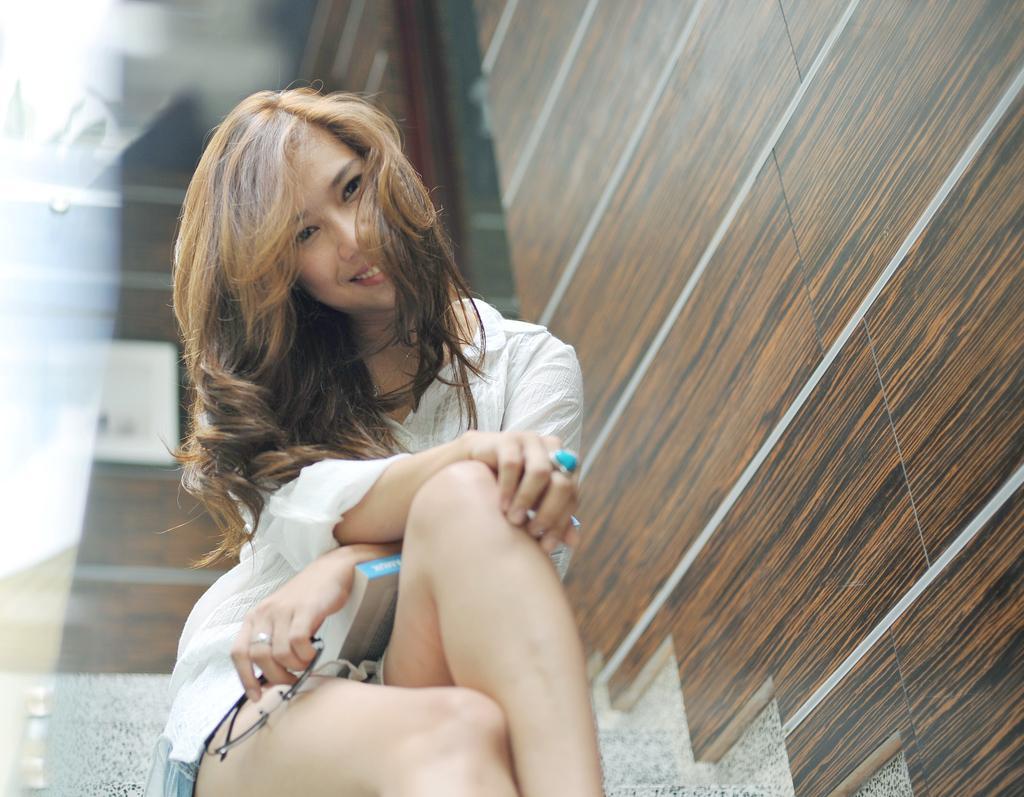In one or two sentences, can you explain what this image depicts? In the image we can see a girl sitting, wearing clothes and finger ring. She is holding spectacles and there is a book on her lap. Here we can see wooden wall and the background is blurred. 